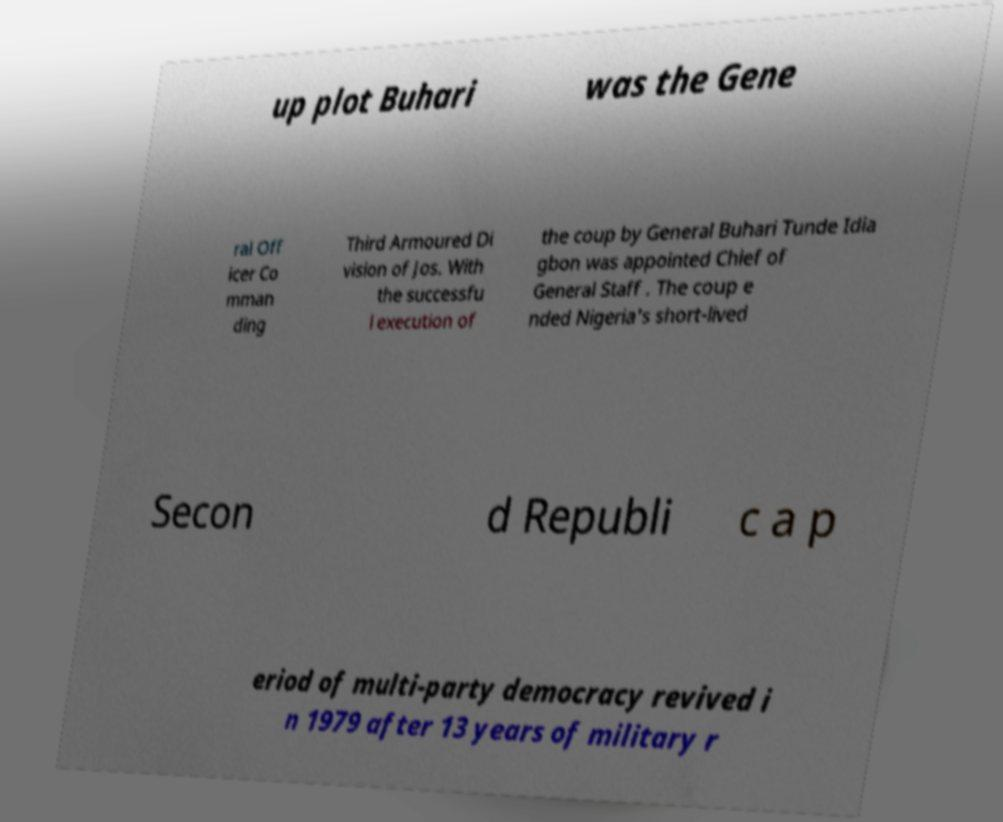Could you assist in decoding the text presented in this image and type it out clearly? up plot Buhari was the Gene ral Off icer Co mman ding Third Armoured Di vision of Jos. With the successfu l execution of the coup by General Buhari Tunde Idia gbon was appointed Chief of General Staff . The coup e nded Nigeria's short-lived Secon d Republi c a p eriod of multi-party democracy revived i n 1979 after 13 years of military r 